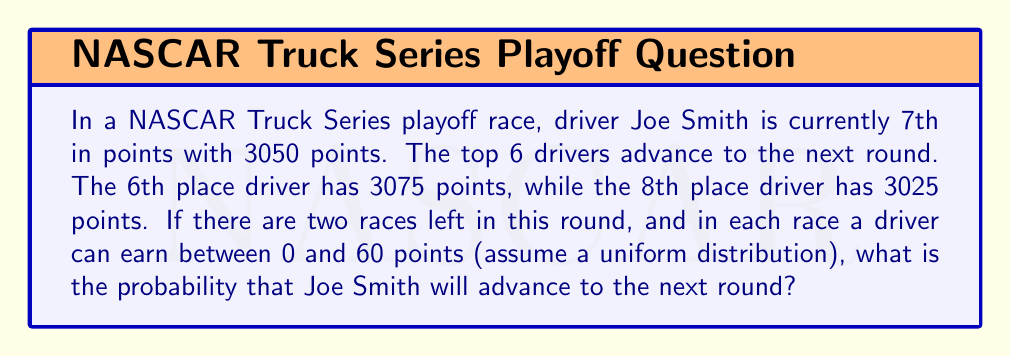Can you answer this question? Let's approach this step-by-step:

1) Joe needs to gain at least 26 points over the next two races to pass the 6th place driver (3075 - 3050 = 25, so 26 to surpass).

2) The total points Joe can earn over two races is uniformly distributed between 0 and 120 (60 * 2).

3) Joe needs to earn more than 25 points AND earn more points than the 6th place driver gains.

4) Let $X$ be Joe's points gained and $Y$ be the 6th place driver's points gained.

5) We need to find $P(X > 25 \text{ and } X > Y)$.

6) This can be calculated as:

   $$P(X > 25 \text{ and } X > Y) = \int_{25}^{120} \int_{0}^{x} f_X(x) f_Y(y) dy dx$$

   Where $f_X(x)$ and $f_Y(y)$ are the probability density functions for $X$ and $Y$.

7) For a uniform distribution between 0 and 120, the PDF is $\frac{1}{120}$.

8) Substituting:

   $$P(X > 25 \text{ and } X > Y) = \int_{25}^{120} \int_{0}^{x} \frac{1}{120} \frac{1}{120} dy dx$$

9) Solving the inner integral:

   $$= \int_{25}^{120} [\frac{y}{120^2}]_{0}^{x} dx = \int_{25}^{120} \frac{x}{120^2} dx$$

10) Solving the outer integral:

    $$= [\frac{x^2}{2(120^2)}]_{25}^{120} = \frac{120^2}{2(120^2)} - \frac{25^2}{2(120^2)} = \frac{1}{2} - \frac{625}{28800} = \frac{13675}{28800}$$

11) Therefore, the probability is $\frac{13675}{28800} \approx 0.4748$ or about 47.48%.
Answer: $\frac{13675}{28800}$ or approximately 0.4748 